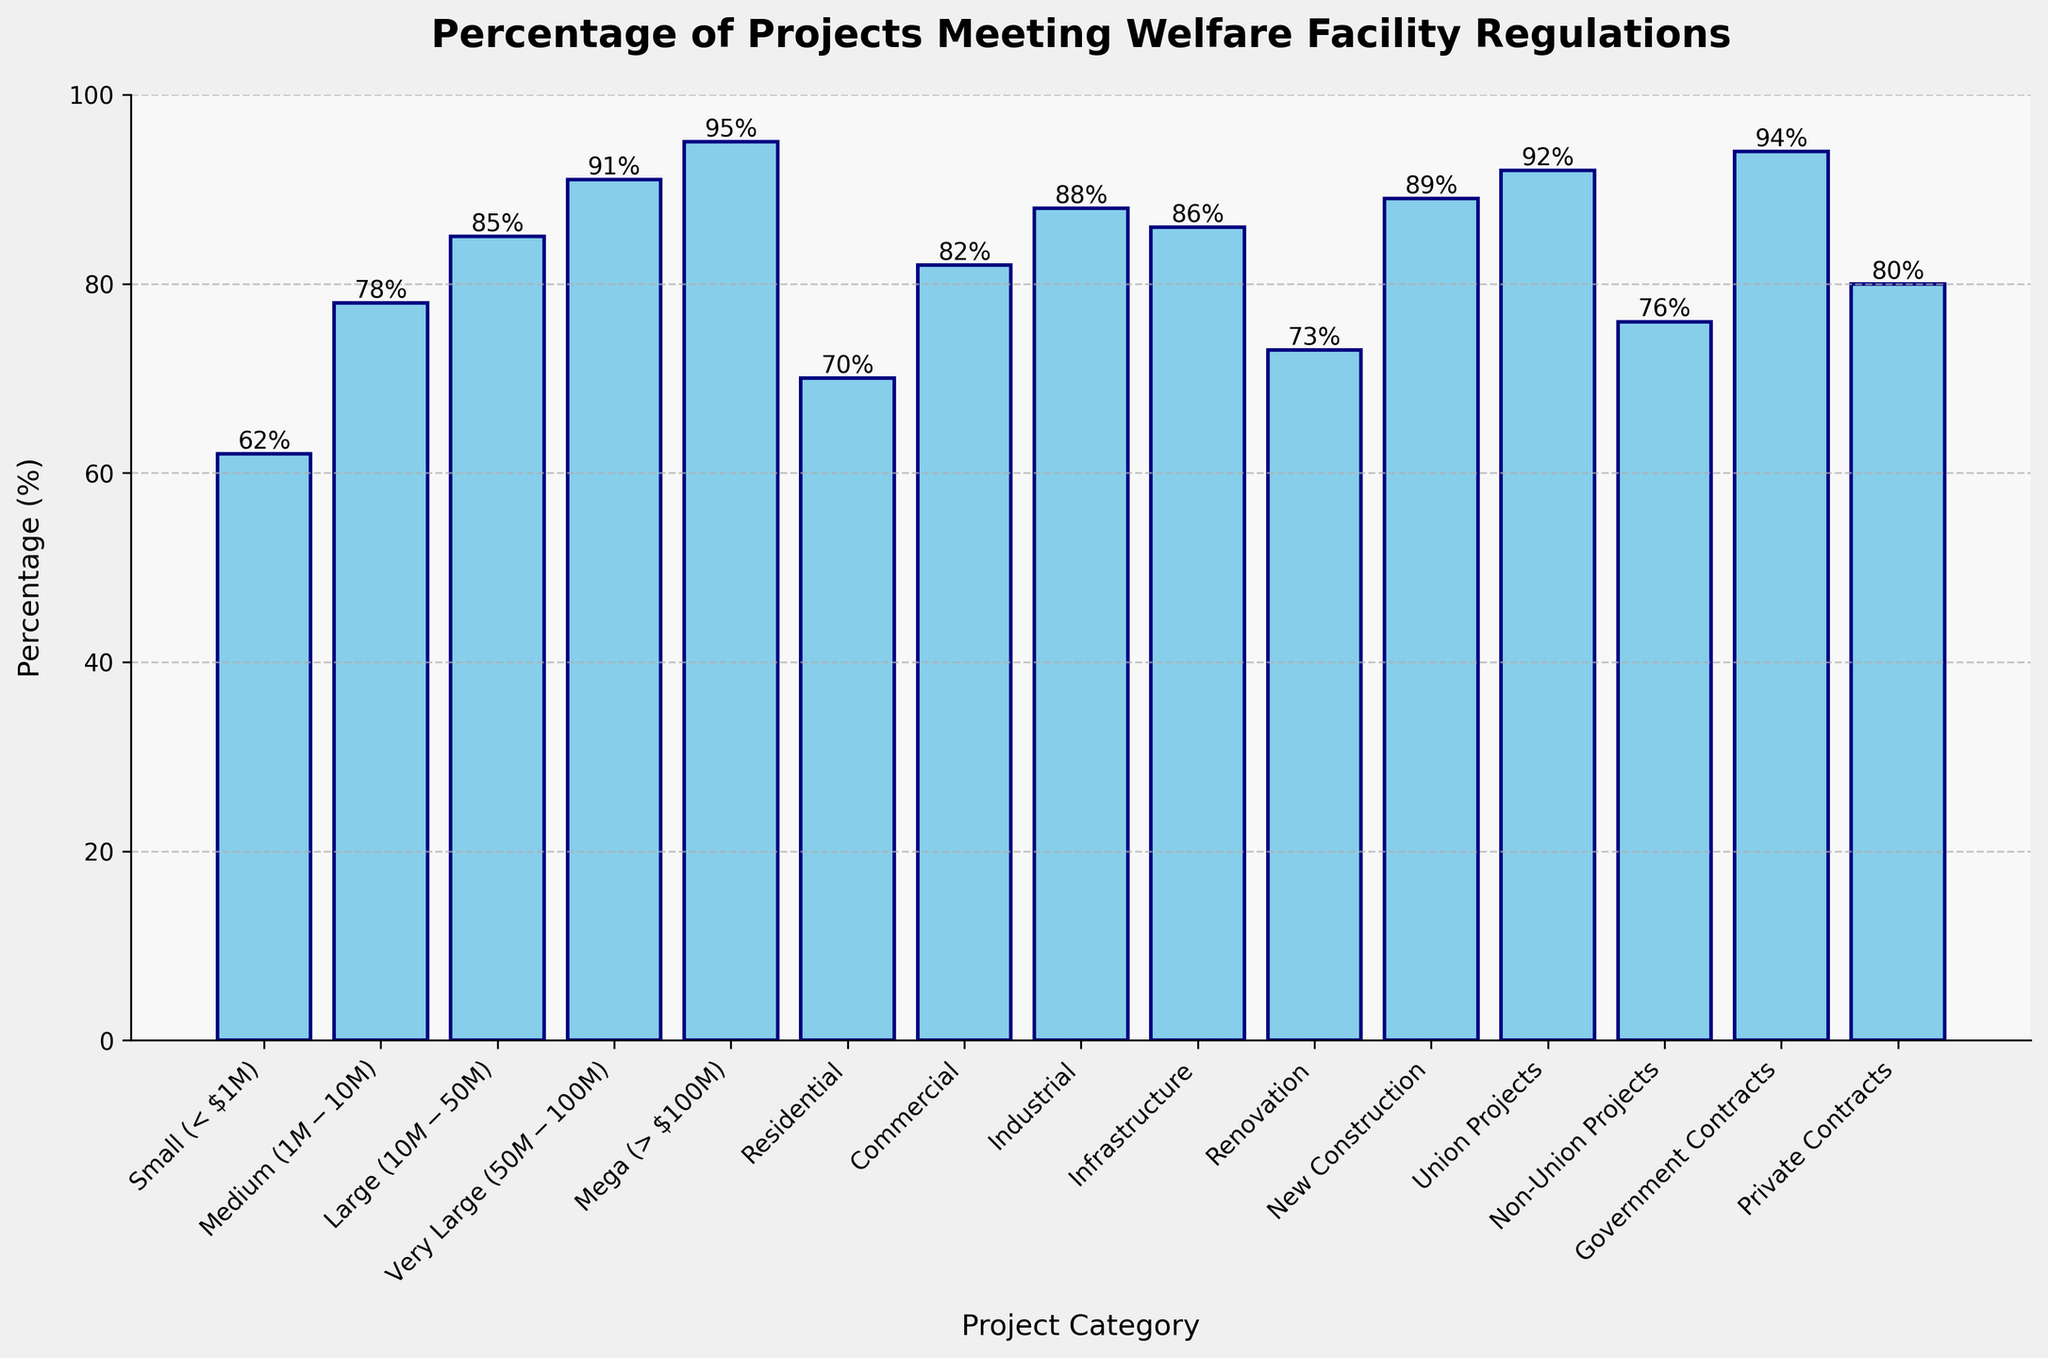Which project size category meets or exceeds welfare facility regulations the most? Identify the bar with the highest value, which corresponds to the project size category with the highest percentage. The "Mega (> $100M)" category has the highest percentage at 95%.
Answer: Mega (> $100M) Which category has a higher percentage meeting welfare facility regulations: Residential or Commercial? Compare the heights of the bars for "Residential" (at 70%) and "Commercial" (at 82%). Commercial has a higher percentage than Residential.
Answer: Commercial What is the difference in the percentage meeting regulations between Very Large ($50M - $100M) and Small (< $1M) projects? Find the percentage values for both categories: Very Large is 91% and Small is 62%. Subtract the Smaller percentage from the Very Large to get the difference (91% - 62% = 29%).
Answer: 29% What is the combined average percentage of projects meeting regulations for Medium ($1M - $10M) and Large ($10M - $50M) projects? Add the two percentages: Medium is 78% and Large is 85%. The sum is 163%. Divide by 2 to find the average (163 / 2 = 81.5%).
Answer: 81.5% Do government contracts meet welfare facility regulations more often than private contracts? Compare the heights of the bars for "Government Contracts" (at 94%) and "Private Contracts" (at 80%). The bar for Government Contracts is higher.
Answer: Yes Among Union projects and Non-Union projects, which has a higher compliance percentage? Compare the heights of the bars for "Union Projects" (at 92%) and "Non-Union Projects" (at 76%). Union Projects have a higher compliance percentage.
Answer: Union Projects How does the compliance rate of New Construction compare to the overall infrastructure projects? Compare the "New Construction" (at 89%) to "Infrastructure" (at 86%). The "New Construction" bar is slightly higher.
Answer: New Construction What are the three categories with the lowest compliance percentages? Identify the three bars with the lowest heights: "Small (< $1M)" at 62%, "Residential" at 70%, and "Renovation" at 73%.
Answer: Small (< $1M), Residential, Renovation Which has a higher compliance rate: Industrial projects or Infrastructure projects? Compare the heights of the bars for "Industrial" (at 88%) and "Infrastructure" (at 86%). The "Industrial" bar is higher.
Answer: Industrial What is the difference in the compliance rate between Commercial and Private Contracts? Find the percentage values: Commercial is at 82% and Private Contracts at 80%. Subtract Private Contracts from Commercial (82% - 80% = 2%).
Answer: 2% 